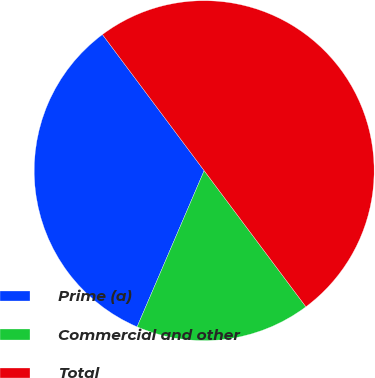Convert chart to OTSL. <chart><loc_0><loc_0><loc_500><loc_500><pie_chart><fcel>Prime (a)<fcel>Commercial and other<fcel>Total<nl><fcel>33.33%<fcel>16.67%<fcel>50.0%<nl></chart> 